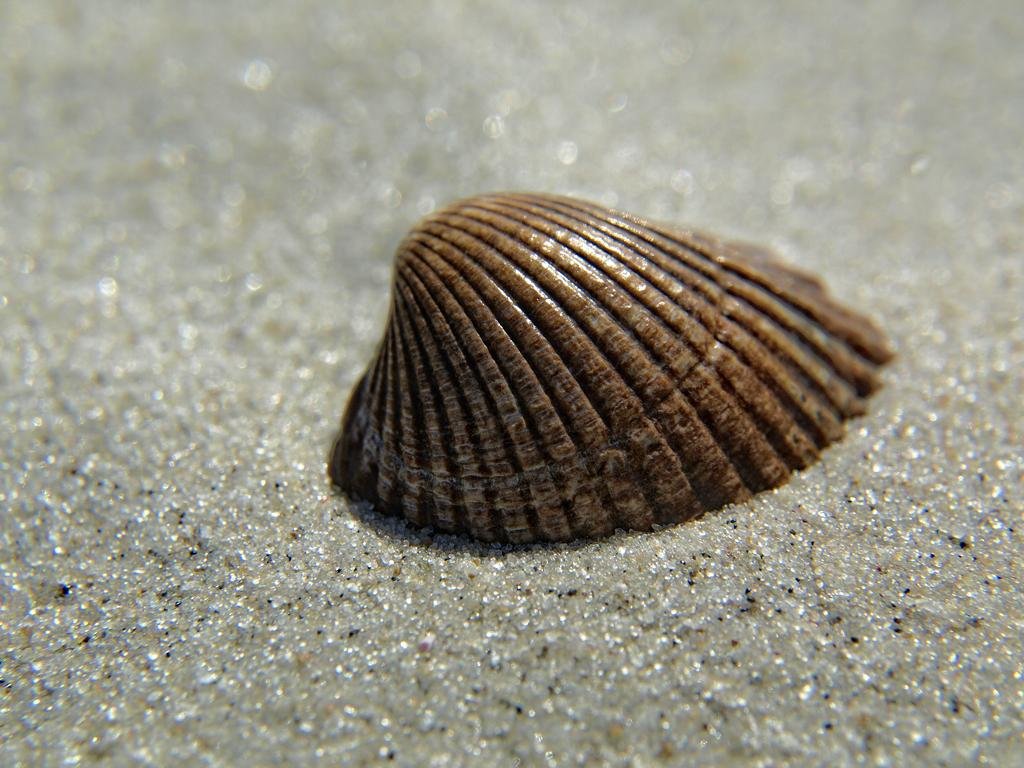What is located in the sand in the image? There is a sea shell in the sand. What type of creature can be seen interacting with the sea shell in the image? There is no creature present in the image; it only features a sea shell in the sand. How many cows are visible in the image? There are no cows present in the image. 